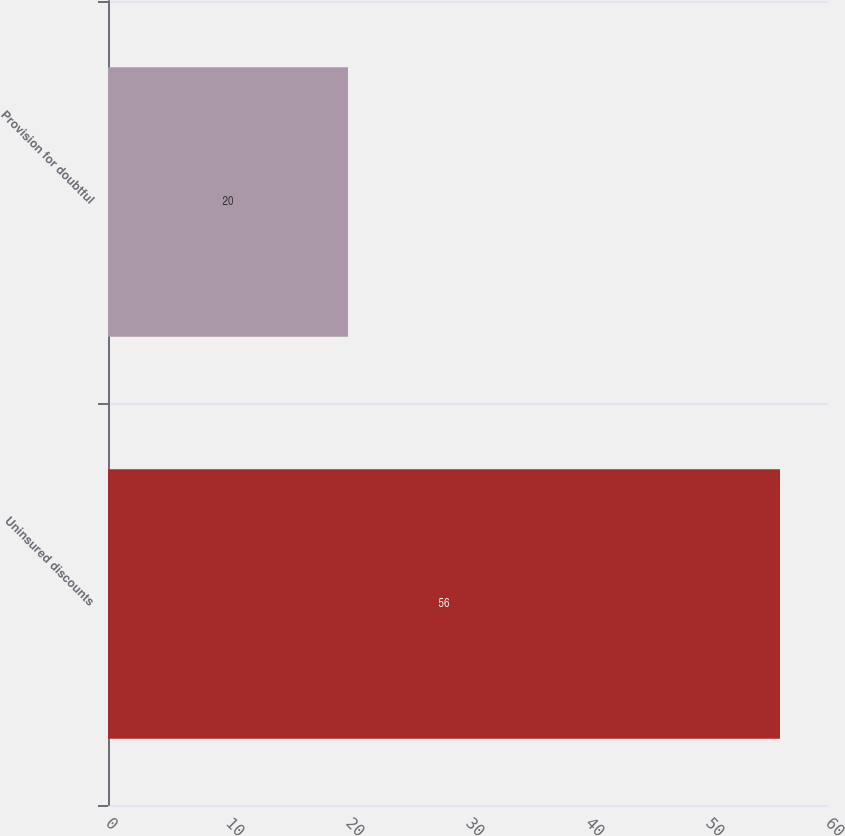<chart> <loc_0><loc_0><loc_500><loc_500><bar_chart><fcel>Uninsured discounts<fcel>Provision for doubtful<nl><fcel>56<fcel>20<nl></chart> 